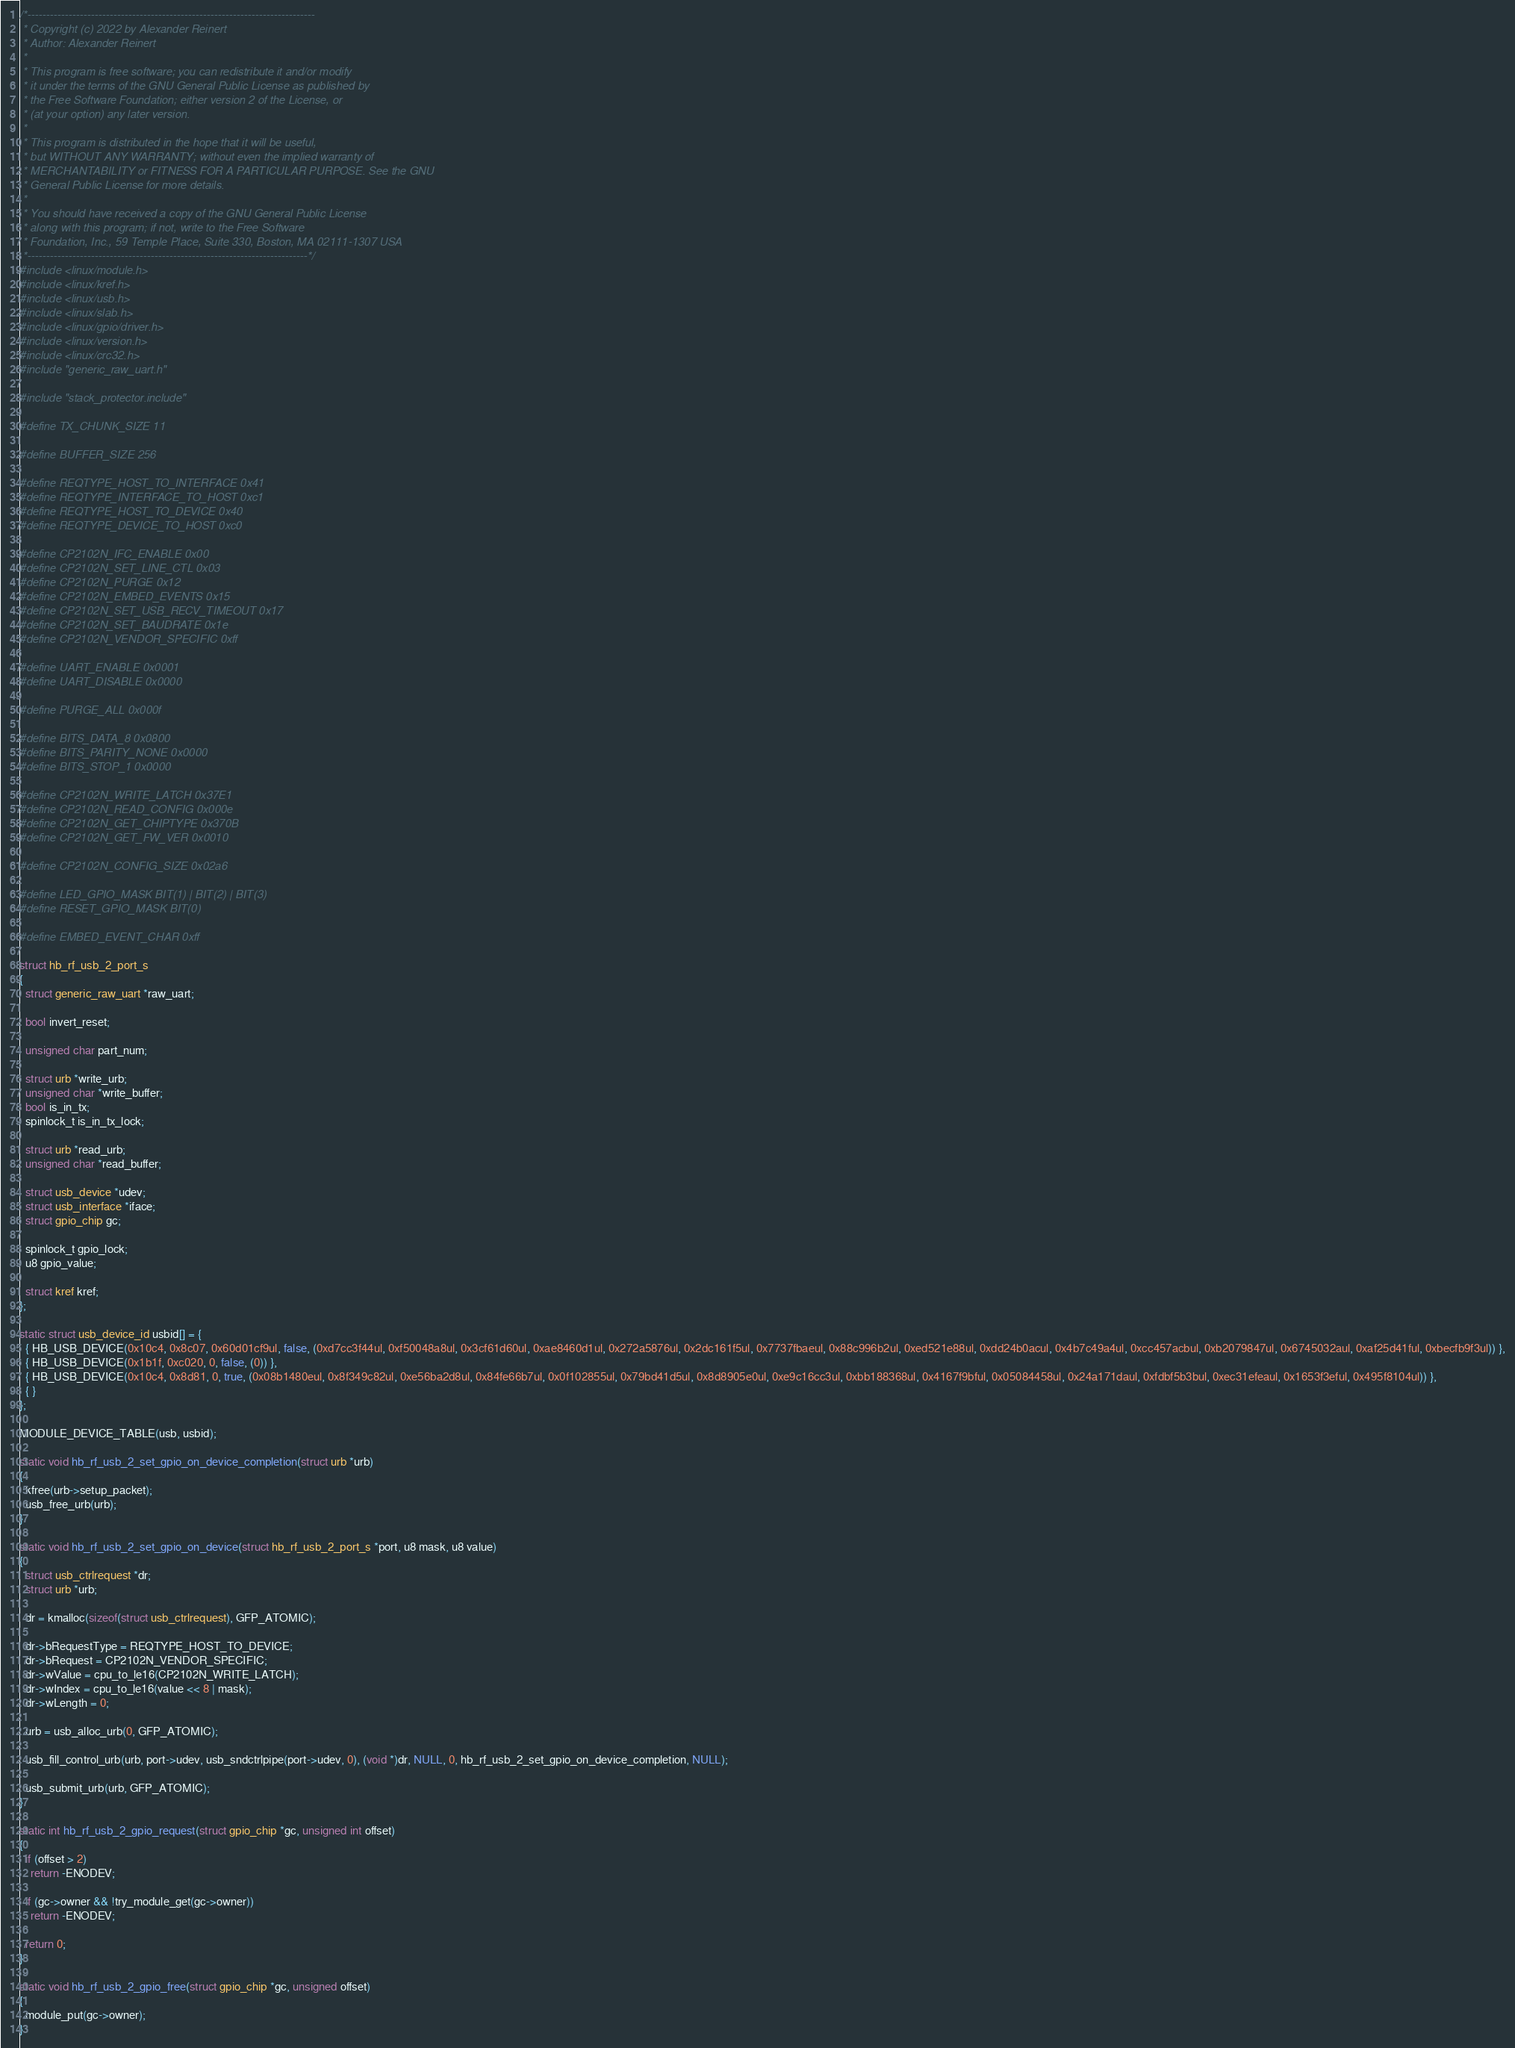Convert code to text. <code><loc_0><loc_0><loc_500><loc_500><_C_>/*-----------------------------------------------------------------------------
 * Copyright (c) 2022 by Alexander Reinert
 * Author: Alexander Reinert
 *
 * This program is free software; you can redistribute it and/or modify
 * it under the terms of the GNU General Public License as published by
 * the Free Software Foundation; either version 2 of the License, or
 * (at your option) any later version.
 *
 * This program is distributed in the hope that it will be useful,
 * but WITHOUT ANY WARRANTY; without even the implied warranty of
 * MERCHANTABILITY or FITNESS FOR A PARTICULAR PURPOSE. See the GNU
 * General Public License for more details.
 *
 * You should have received a copy of the GNU General Public License
 * along with this program; if not, write to the Free Software
 * Foundation, Inc., 59 Temple Place, Suite 330, Boston, MA 02111-1307 USA
 *---------------------------------------------------------------------------*/
#include <linux/module.h>
#include <linux/kref.h>
#include <linux/usb.h>
#include <linux/slab.h>
#include <linux/gpio/driver.h>
#include <linux/version.h>
#include <linux/crc32.h>
#include "generic_raw_uart.h"

#include "stack_protector.include"

#define TX_CHUNK_SIZE 11

#define BUFFER_SIZE 256

#define REQTYPE_HOST_TO_INTERFACE 0x41
#define REQTYPE_INTERFACE_TO_HOST 0xc1
#define REQTYPE_HOST_TO_DEVICE 0x40
#define REQTYPE_DEVICE_TO_HOST 0xc0

#define CP2102N_IFC_ENABLE 0x00
#define CP2102N_SET_LINE_CTL 0x03
#define CP2102N_PURGE 0x12
#define CP2102N_EMBED_EVENTS 0x15
#define CP2102N_SET_USB_RECV_TIMEOUT 0x17
#define CP2102N_SET_BAUDRATE 0x1e
#define CP2102N_VENDOR_SPECIFIC 0xff

#define UART_ENABLE 0x0001
#define UART_DISABLE 0x0000

#define PURGE_ALL 0x000f

#define BITS_DATA_8 0x0800
#define BITS_PARITY_NONE 0x0000
#define BITS_STOP_1 0x0000

#define CP2102N_WRITE_LATCH 0x37E1
#define CP2102N_READ_CONFIG 0x000e
#define CP2102N_GET_CHIPTYPE 0x370B
#define CP2102N_GET_FW_VER 0x0010

#define CP2102N_CONFIG_SIZE 0x02a6

#define LED_GPIO_MASK BIT(1) | BIT(2) | BIT(3)
#define RESET_GPIO_MASK BIT(0)

#define EMBED_EVENT_CHAR 0xff

struct hb_rf_usb_2_port_s
{
  struct generic_raw_uart *raw_uart;

  bool invert_reset;

  unsigned char part_num;

  struct urb *write_urb;
  unsigned char *write_buffer;
  bool is_in_tx;
  spinlock_t is_in_tx_lock;

  struct urb *read_urb;
  unsigned char *read_buffer;

  struct usb_device *udev;
  struct usb_interface *iface;
  struct gpio_chip gc;

  spinlock_t gpio_lock;
  u8 gpio_value;

  struct kref kref;
};

static struct usb_device_id usbid[] = {
  { HB_USB_DEVICE(0x10c4, 0x8c07, 0x60d01cf9ul, false, (0xd7cc3f44ul, 0xf50048a8ul, 0x3cf61d60ul, 0xae8460d1ul, 0x272a5876ul, 0x2dc161f5ul, 0x7737fbaeul, 0x88c996b2ul, 0xed521e88ul, 0xdd24b0acul, 0x4b7c49a4ul, 0xcc457acbul, 0xb2079847ul, 0x6745032aul, 0xaf25d41ful, 0xbecfb9f3ul)) },
  { HB_USB_DEVICE(0x1b1f, 0xc020, 0, false, (0)) },
  { HB_USB_DEVICE(0x10c4, 0x8d81, 0, true, (0x08b1480eul, 0x8f349c82ul, 0xe56ba2d8ul, 0x84fe66b7ul, 0x0f102855ul, 0x79bd41d5ul, 0x8d8905e0ul, 0xe9c16cc3ul, 0xbb188368ul, 0x4167f9bful, 0x05084458ul, 0x24a171daul, 0xfdbf5b3bul, 0xec31efeaul, 0x1653f3eful, 0x495f8104ul)) },
  { }
};

MODULE_DEVICE_TABLE(usb, usbid);

static void hb_rf_usb_2_set_gpio_on_device_completion(struct urb *urb)
{
  kfree(urb->setup_packet);
  usb_free_urb(urb);
}

static void hb_rf_usb_2_set_gpio_on_device(struct hb_rf_usb_2_port_s *port, u8 mask, u8 value)
{
  struct usb_ctrlrequest *dr;
  struct urb *urb;

  dr = kmalloc(sizeof(struct usb_ctrlrequest), GFP_ATOMIC);

  dr->bRequestType = REQTYPE_HOST_TO_DEVICE;
  dr->bRequest = CP2102N_VENDOR_SPECIFIC;
  dr->wValue = cpu_to_le16(CP2102N_WRITE_LATCH);
  dr->wIndex = cpu_to_le16(value << 8 | mask);
  dr->wLength = 0;

  urb = usb_alloc_urb(0, GFP_ATOMIC);

  usb_fill_control_urb(urb, port->udev, usb_sndctrlpipe(port->udev, 0), (void *)dr, NULL, 0, hb_rf_usb_2_set_gpio_on_device_completion, NULL);

  usb_submit_urb(urb, GFP_ATOMIC);
}

static int hb_rf_usb_2_gpio_request(struct gpio_chip *gc, unsigned int offset)
{
  if (offset > 2)
    return -ENODEV;

  if (gc->owner && !try_module_get(gc->owner))
    return -ENODEV;

  return 0;
}

static void hb_rf_usb_2_gpio_free(struct gpio_chip *gc, unsigned offset)
{
  module_put(gc->owner);
}
</code> 